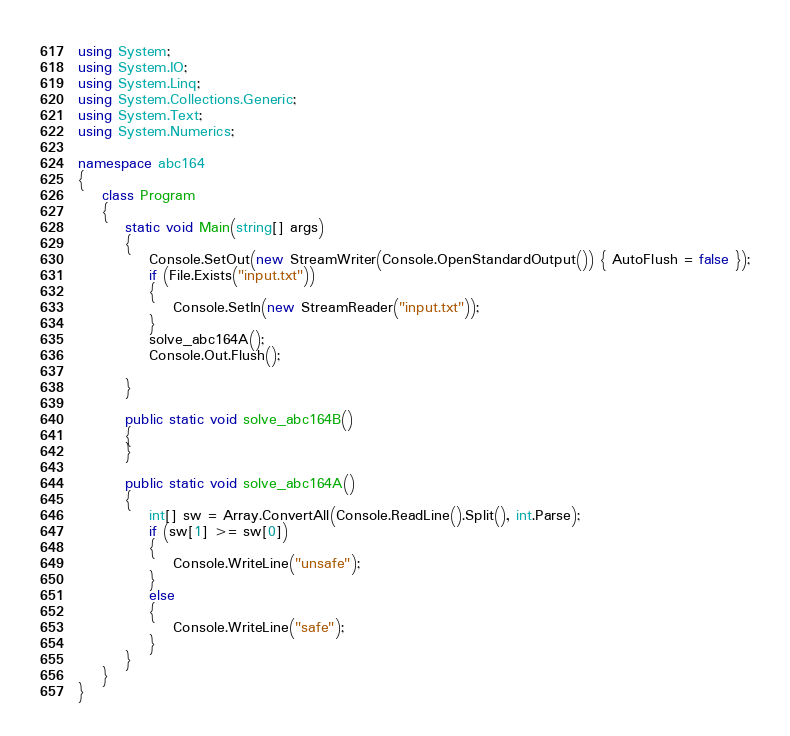Convert code to text. <code><loc_0><loc_0><loc_500><loc_500><_C#_>using System;
using System.IO;
using System.Linq;
using System.Collections.Generic;
using System.Text;
using System.Numerics;

namespace abc164
{
    class Program
    {
        static void Main(string[] args)
        {
            Console.SetOut(new StreamWriter(Console.OpenStandardOutput()) { AutoFlush = false });
            if (File.Exists("input.txt"))
            {
                Console.SetIn(new StreamReader("input.txt"));
            }
			solve_abc164A();
			Console.Out.Flush();

        }

        public static void solve_abc164B()
        {
        }

        public static void solve_abc164A()
        {
            int[] sw = Array.ConvertAll(Console.ReadLine().Split(), int.Parse);
            if (sw[1] >= sw[0])
            {
                Console.WriteLine("unsafe");
            }
            else
            {
                Console.WriteLine("safe");
            }
        }
    }
}
</code> 